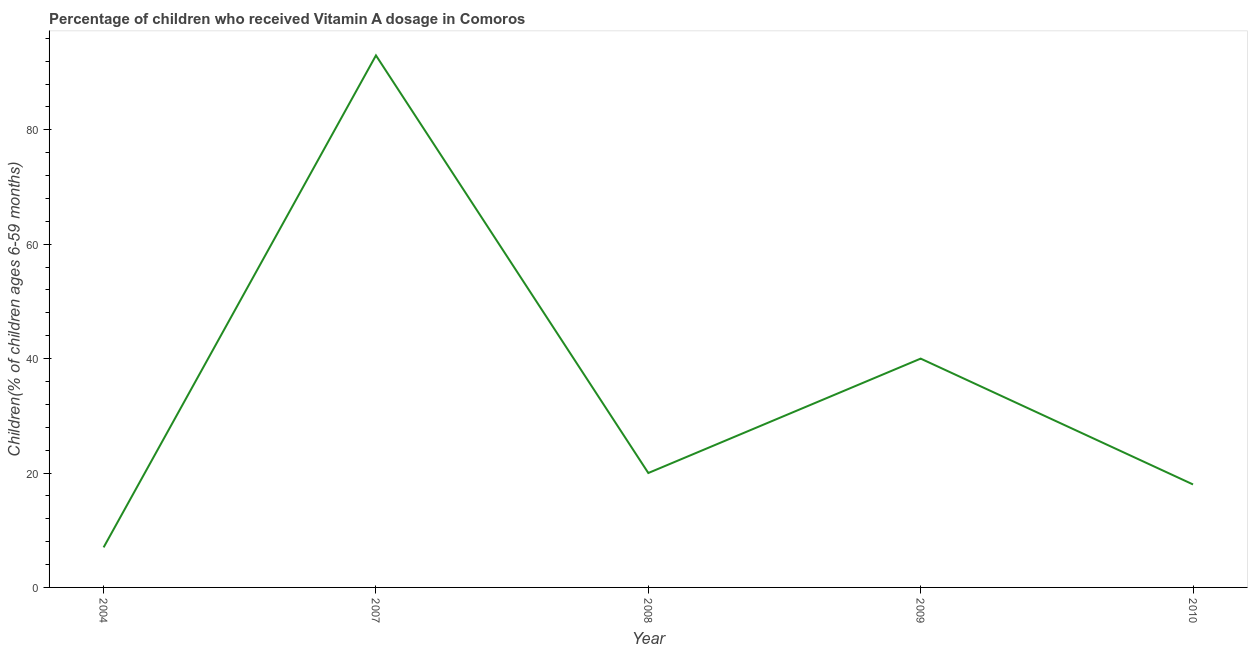What is the vitamin a supplementation coverage rate in 2007?
Provide a short and direct response. 93. Across all years, what is the maximum vitamin a supplementation coverage rate?
Make the answer very short. 93. Across all years, what is the minimum vitamin a supplementation coverage rate?
Ensure brevity in your answer.  7. In which year was the vitamin a supplementation coverage rate maximum?
Offer a terse response. 2007. What is the sum of the vitamin a supplementation coverage rate?
Your response must be concise. 178. What is the difference between the vitamin a supplementation coverage rate in 2004 and 2007?
Your response must be concise. -86. What is the average vitamin a supplementation coverage rate per year?
Your response must be concise. 35.6. What is the ratio of the vitamin a supplementation coverage rate in 2008 to that in 2010?
Keep it short and to the point. 1.11. What is the difference between the highest and the second highest vitamin a supplementation coverage rate?
Provide a short and direct response. 53. What is the difference between the highest and the lowest vitamin a supplementation coverage rate?
Provide a short and direct response. 86. In how many years, is the vitamin a supplementation coverage rate greater than the average vitamin a supplementation coverage rate taken over all years?
Your answer should be compact. 2. How many lines are there?
Keep it short and to the point. 1. Are the values on the major ticks of Y-axis written in scientific E-notation?
Make the answer very short. No. Does the graph contain any zero values?
Your answer should be very brief. No. What is the title of the graph?
Offer a terse response. Percentage of children who received Vitamin A dosage in Comoros. What is the label or title of the X-axis?
Your answer should be very brief. Year. What is the label or title of the Y-axis?
Provide a short and direct response. Children(% of children ages 6-59 months). What is the Children(% of children ages 6-59 months) in 2007?
Provide a short and direct response. 93. What is the Children(% of children ages 6-59 months) of 2008?
Offer a very short reply. 20. What is the Children(% of children ages 6-59 months) of 2009?
Provide a short and direct response. 40. What is the Children(% of children ages 6-59 months) in 2010?
Provide a succinct answer. 18. What is the difference between the Children(% of children ages 6-59 months) in 2004 and 2007?
Your answer should be very brief. -86. What is the difference between the Children(% of children ages 6-59 months) in 2004 and 2008?
Offer a terse response. -13. What is the difference between the Children(% of children ages 6-59 months) in 2004 and 2009?
Keep it short and to the point. -33. What is the difference between the Children(% of children ages 6-59 months) in 2004 and 2010?
Your answer should be compact. -11. What is the difference between the Children(% of children ages 6-59 months) in 2007 and 2008?
Your answer should be compact. 73. What is the difference between the Children(% of children ages 6-59 months) in 2007 and 2010?
Provide a short and direct response. 75. What is the difference between the Children(% of children ages 6-59 months) in 2008 and 2010?
Your answer should be very brief. 2. What is the difference between the Children(% of children ages 6-59 months) in 2009 and 2010?
Give a very brief answer. 22. What is the ratio of the Children(% of children ages 6-59 months) in 2004 to that in 2007?
Give a very brief answer. 0.07. What is the ratio of the Children(% of children ages 6-59 months) in 2004 to that in 2009?
Keep it short and to the point. 0.17. What is the ratio of the Children(% of children ages 6-59 months) in 2004 to that in 2010?
Provide a succinct answer. 0.39. What is the ratio of the Children(% of children ages 6-59 months) in 2007 to that in 2008?
Keep it short and to the point. 4.65. What is the ratio of the Children(% of children ages 6-59 months) in 2007 to that in 2009?
Your answer should be very brief. 2.33. What is the ratio of the Children(% of children ages 6-59 months) in 2007 to that in 2010?
Offer a terse response. 5.17. What is the ratio of the Children(% of children ages 6-59 months) in 2008 to that in 2010?
Keep it short and to the point. 1.11. What is the ratio of the Children(% of children ages 6-59 months) in 2009 to that in 2010?
Offer a very short reply. 2.22. 